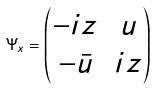Convert formula to latex. <formula><loc_0><loc_0><loc_500><loc_500>\Psi _ { x } = \left ( \begin{matrix} - i z & u \\ - \bar { u } & i z \end{matrix} \right )</formula> 